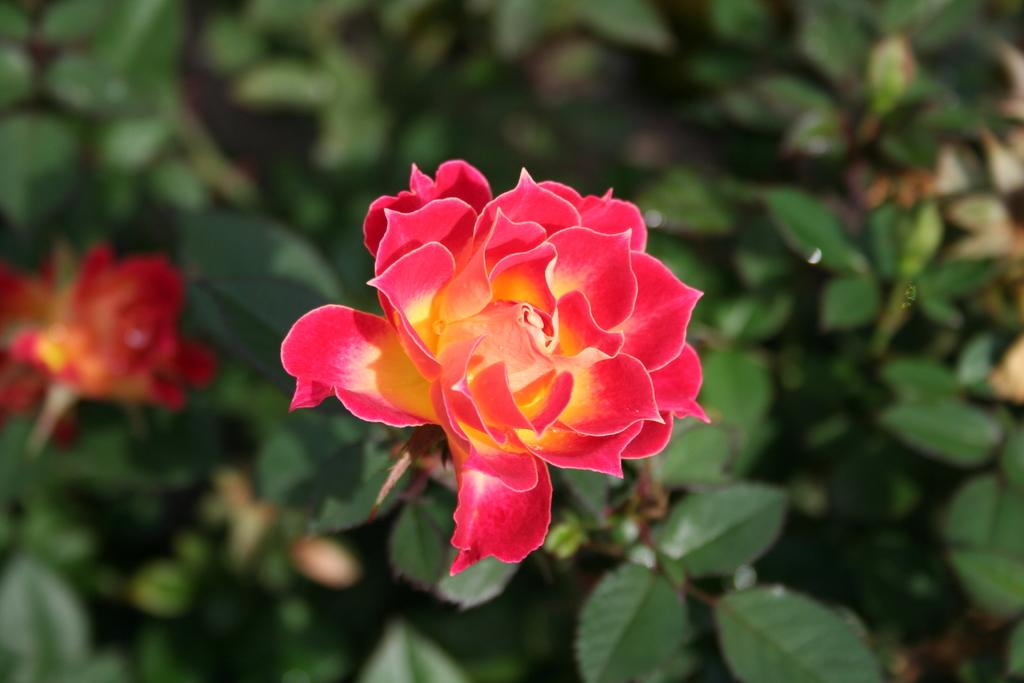What color are the flowers in the image? The flowers in the image are red. What color are the leaves in the image? The leaves in the image are green. Can you describe the background of the image? The background of the image is blurred. How many quivers can be seen in the image? There are no quivers present in the image. Can you hear the flowers crying in the image? The flowers do not make any sounds in the image, so they cannot be heard crying. 